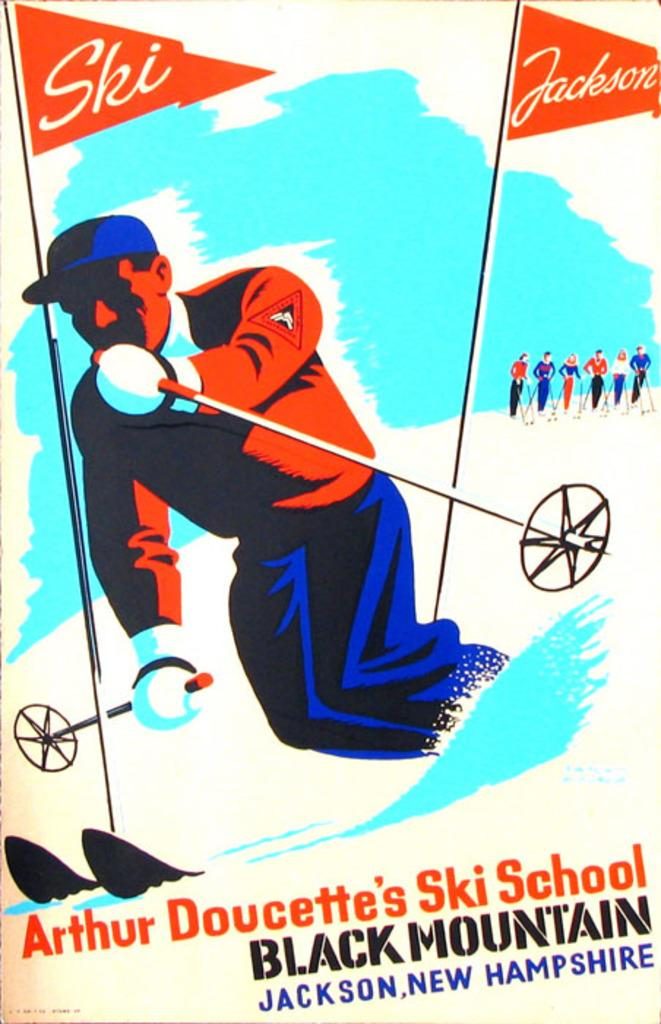Who is present in the image? There is a man in the image. What is the man standing on in the image? The man is on the snow in the image. What other objects can be seen in the image? There are flags in the image. Is there any text included in the image? Yes, there is text at the bottom of the image. What type of artwork is the image? The image is a painting. What type of umbrella is the man holding in the image? There is no umbrella present in the image; the man is standing on snow. What angle is the painting displayed at in the image? The image does not show the painting being displayed at any specific angle. 